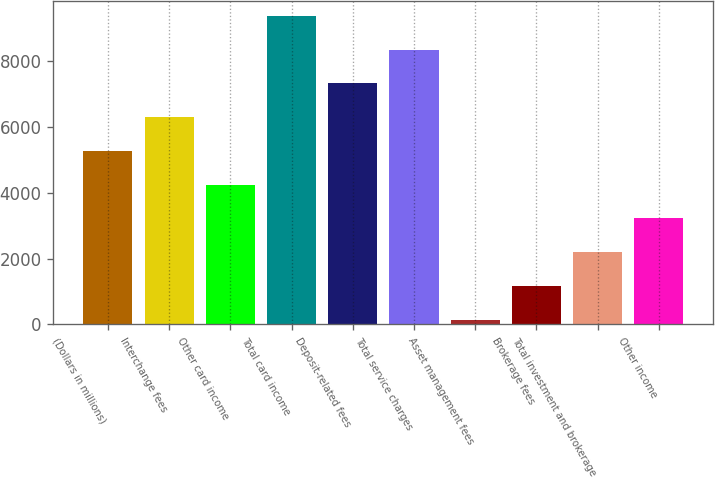<chart> <loc_0><loc_0><loc_500><loc_500><bar_chart><fcel>(Dollars in millions)<fcel>Interchange fees<fcel>Other card income<fcel>Total card income<fcel>Deposit-related fees<fcel>Total service charges<fcel>Asset management fees<fcel>Brokerage fees<fcel>Total investment and brokerage<fcel>Other income<nl><fcel>5273.5<fcel>6298.8<fcel>4248.2<fcel>9374.7<fcel>7324.1<fcel>8349.4<fcel>147<fcel>1172.3<fcel>2197.6<fcel>3222.9<nl></chart> 